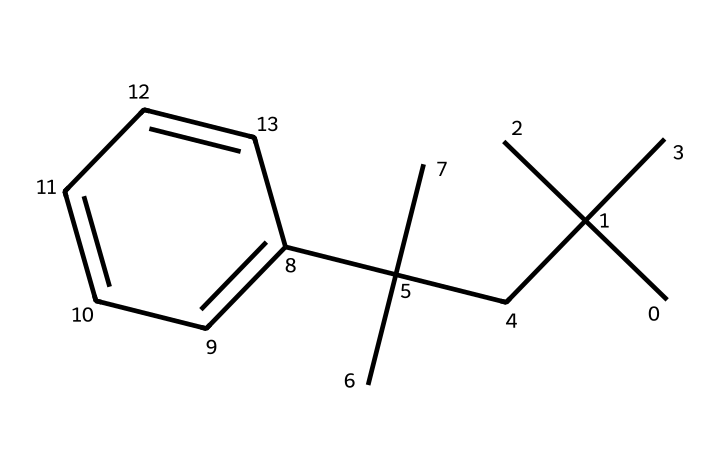What is the chemical name of this structure? The SMILES representation indicates a structure with a combination of carbon and hydrogen, which corresponds to polystyrene, a polymer.
Answer: polystyrene How many carbon atoms are present in this molecule? By analyzing the structure encoded in the SMILES, we count a total of 15 carbon atoms that make up the backbone and substituents of the polymer.
Answer: 15 What type of polymer is represented by this structure? This molecule is identified as a thermoplastic polymer due to its linear structure consisting of repeating units that can soften upon heating.
Answer: thermoplastic How many double bonds are in the structure? The SMILES does not denote any double bonds; it showcases a fully saturated hydrocarbon chain, indicating that no double bonds are present.
Answer: 0 What is the approximate molecular weight of polystyrene represented by this structure? Given the presence of 15 carbon atoms and 16 hydrogen atoms, we can calculate the molecular weight based on the atomic weights (C=12.01, H=1.008) resulting in an approximate weight of 180.24 g/mol.
Answer: 180.24 What characteristic of this polymer makes it suitable for disposable applications? Polystyrene exhibits lightweight and rigid properties, leading to its widespread use in disposable items such as coffee cup lids that can easily be manufactured at low cost.
Answer: lightweight and rigid How does the branched structure in this chemical affect its properties? The branched structure of polystyrene affects its crystallinity and physical properties, creating a less dense arrangement, which provides good insulating properties and contributes to its overall durability.
Answer: affects crystallinity 